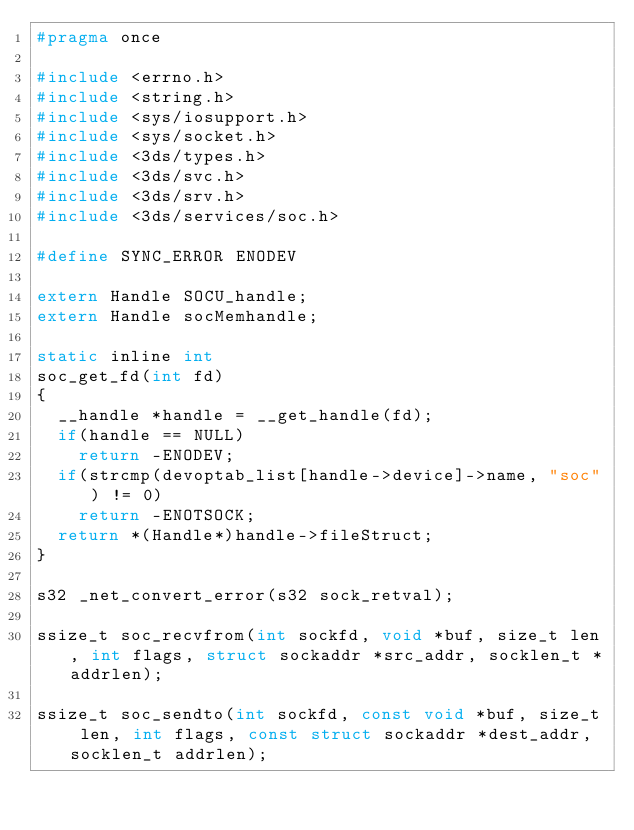<code> <loc_0><loc_0><loc_500><loc_500><_C_>#pragma once

#include <errno.h>
#include <string.h>
#include <sys/iosupport.h>
#include <sys/socket.h>
#include <3ds/types.h>
#include <3ds/svc.h>
#include <3ds/srv.h>
#include <3ds/services/soc.h>

#define SYNC_ERROR ENODEV

extern Handle	SOCU_handle;
extern Handle	socMemhandle;

static inline int
soc_get_fd(int fd)
{
	__handle *handle = __get_handle(fd);
	if(handle == NULL)
		return -ENODEV;
	if(strcmp(devoptab_list[handle->device]->name, "soc") != 0)
		return -ENOTSOCK;
	return *(Handle*)handle->fileStruct;
}

s32 _net_convert_error(s32 sock_retval);

ssize_t soc_recvfrom(int sockfd, void *buf, size_t len, int flags, struct sockaddr *src_addr, socklen_t *addrlen);

ssize_t soc_sendto(int sockfd, const void *buf, size_t len, int flags, const struct sockaddr *dest_addr, socklen_t addrlen);
</code> 